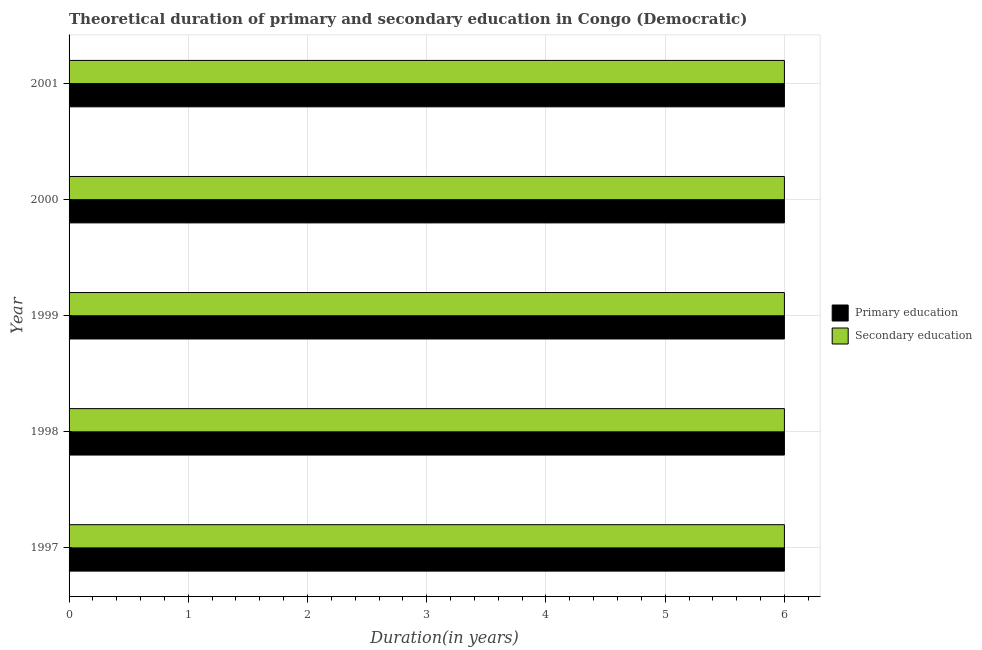How many different coloured bars are there?
Keep it short and to the point. 2. How many groups of bars are there?
Offer a very short reply. 5. Are the number of bars per tick equal to the number of legend labels?
Offer a terse response. Yes. How many bars are there on the 2nd tick from the bottom?
Offer a very short reply. 2. What is the label of the 5th group of bars from the top?
Make the answer very short. 1997. Across all years, what is the maximum duration of primary education?
Your answer should be very brief. 6. Across all years, what is the minimum duration of secondary education?
Offer a very short reply. 6. In which year was the duration of primary education maximum?
Offer a terse response. 1997. What is the total duration of secondary education in the graph?
Provide a succinct answer. 30. What is the difference between the duration of primary education in 1997 and that in 2000?
Offer a terse response. 0. What is the average duration of secondary education per year?
Ensure brevity in your answer.  6. In the year 2000, what is the difference between the duration of secondary education and duration of primary education?
Your answer should be compact. 0. What is the ratio of the duration of primary education in 1998 to that in 2000?
Make the answer very short. 1. Is the difference between the duration of secondary education in 1997 and 1999 greater than the difference between the duration of primary education in 1997 and 1999?
Ensure brevity in your answer.  No. What is the difference between the highest and the lowest duration of secondary education?
Keep it short and to the point. 0. In how many years, is the duration of primary education greater than the average duration of primary education taken over all years?
Your answer should be very brief. 0. What does the 2nd bar from the bottom in 1997 represents?
Keep it short and to the point. Secondary education. How many years are there in the graph?
Make the answer very short. 5. What is the difference between two consecutive major ticks on the X-axis?
Ensure brevity in your answer.  1. Does the graph contain any zero values?
Your answer should be very brief. No. Does the graph contain grids?
Keep it short and to the point. Yes. Where does the legend appear in the graph?
Offer a terse response. Center right. How are the legend labels stacked?
Offer a very short reply. Vertical. What is the title of the graph?
Make the answer very short. Theoretical duration of primary and secondary education in Congo (Democratic). What is the label or title of the X-axis?
Your answer should be compact. Duration(in years). What is the label or title of the Y-axis?
Your response must be concise. Year. What is the Duration(in years) in Secondary education in 1997?
Your answer should be very brief. 6. What is the Duration(in years) in Secondary education in 1998?
Make the answer very short. 6. What is the Duration(in years) of Secondary education in 2000?
Provide a succinct answer. 6. What is the Duration(in years) in Primary education in 2001?
Offer a terse response. 6. Across all years, what is the maximum Duration(in years) of Secondary education?
Give a very brief answer. 6. Across all years, what is the minimum Duration(in years) of Primary education?
Keep it short and to the point. 6. What is the total Duration(in years) of Primary education in the graph?
Give a very brief answer. 30. What is the total Duration(in years) in Secondary education in the graph?
Provide a succinct answer. 30. What is the difference between the Duration(in years) of Primary education in 1997 and that in 1999?
Keep it short and to the point. 0. What is the difference between the Duration(in years) in Secondary education in 1997 and that in 1999?
Keep it short and to the point. 0. What is the difference between the Duration(in years) of Primary education in 1997 and that in 2000?
Offer a terse response. 0. What is the difference between the Duration(in years) of Secondary education in 1997 and that in 2000?
Provide a succinct answer. 0. What is the difference between the Duration(in years) of Secondary education in 1997 and that in 2001?
Offer a terse response. 0. What is the difference between the Duration(in years) in Secondary education in 1998 and that in 2000?
Offer a terse response. 0. What is the difference between the Duration(in years) of Secondary education in 1998 and that in 2001?
Provide a short and direct response. 0. What is the difference between the Duration(in years) in Primary education in 1999 and that in 2000?
Ensure brevity in your answer.  0. What is the difference between the Duration(in years) in Secondary education in 1999 and that in 2000?
Keep it short and to the point. 0. What is the difference between the Duration(in years) in Secondary education in 1999 and that in 2001?
Offer a very short reply. 0. What is the difference between the Duration(in years) of Primary education in 2000 and that in 2001?
Provide a succinct answer. 0. What is the difference between the Duration(in years) of Primary education in 1997 and the Duration(in years) of Secondary education in 1998?
Your answer should be very brief. 0. What is the difference between the Duration(in years) in Primary education in 1997 and the Duration(in years) in Secondary education in 1999?
Make the answer very short. 0. What is the difference between the Duration(in years) of Primary education in 1997 and the Duration(in years) of Secondary education in 2000?
Keep it short and to the point. 0. What is the difference between the Duration(in years) in Primary education in 1997 and the Duration(in years) in Secondary education in 2001?
Provide a short and direct response. 0. What is the difference between the Duration(in years) in Primary education in 1998 and the Duration(in years) in Secondary education in 1999?
Your answer should be very brief. 0. What is the difference between the Duration(in years) in Primary education in 1998 and the Duration(in years) in Secondary education in 2000?
Your answer should be very brief. 0. What is the difference between the Duration(in years) of Primary education in 2000 and the Duration(in years) of Secondary education in 2001?
Your response must be concise. 0. What is the average Duration(in years) in Primary education per year?
Offer a very short reply. 6. In the year 1997, what is the difference between the Duration(in years) in Primary education and Duration(in years) in Secondary education?
Make the answer very short. 0. In the year 1998, what is the difference between the Duration(in years) of Primary education and Duration(in years) of Secondary education?
Provide a succinct answer. 0. In the year 2000, what is the difference between the Duration(in years) of Primary education and Duration(in years) of Secondary education?
Provide a short and direct response. 0. In the year 2001, what is the difference between the Duration(in years) of Primary education and Duration(in years) of Secondary education?
Offer a very short reply. 0. What is the ratio of the Duration(in years) of Secondary education in 1997 to that in 1998?
Provide a succinct answer. 1. What is the ratio of the Duration(in years) of Primary education in 1997 to that in 2000?
Provide a succinct answer. 1. What is the ratio of the Duration(in years) of Secondary education in 1997 to that in 2000?
Offer a terse response. 1. What is the ratio of the Duration(in years) of Primary education in 1997 to that in 2001?
Offer a terse response. 1. What is the ratio of the Duration(in years) in Secondary education in 1997 to that in 2001?
Make the answer very short. 1. What is the ratio of the Duration(in years) of Primary education in 1998 to that in 1999?
Make the answer very short. 1. What is the ratio of the Duration(in years) of Secondary education in 1998 to that in 1999?
Your answer should be compact. 1. What is the ratio of the Duration(in years) of Primary education in 1998 to that in 2000?
Your answer should be very brief. 1. What is the ratio of the Duration(in years) in Secondary education in 1999 to that in 2000?
Offer a very short reply. 1. What is the ratio of the Duration(in years) of Primary education in 1999 to that in 2001?
Provide a succinct answer. 1. What is the ratio of the Duration(in years) in Secondary education in 2000 to that in 2001?
Provide a succinct answer. 1. What is the difference between the highest and the second highest Duration(in years) of Primary education?
Provide a succinct answer. 0. What is the difference between the highest and the second highest Duration(in years) of Secondary education?
Your answer should be very brief. 0. What is the difference between the highest and the lowest Duration(in years) in Secondary education?
Give a very brief answer. 0. 